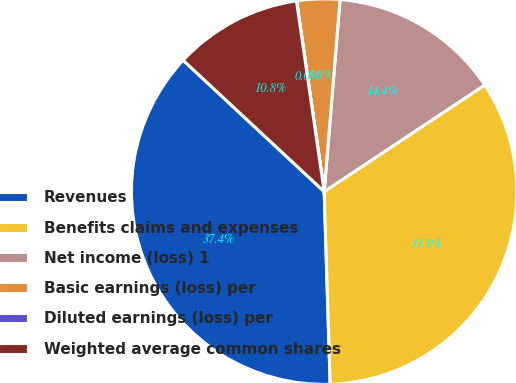Convert chart to OTSL. <chart><loc_0><loc_0><loc_500><loc_500><pie_chart><fcel>Revenues<fcel>Benefits claims and expenses<fcel>Net income (loss) 1<fcel>Basic earnings (loss) per<fcel>Diluted earnings (loss) per<fcel>Weighted average common shares<nl><fcel>37.43%<fcel>33.84%<fcel>14.36%<fcel>3.6%<fcel>0.01%<fcel>10.77%<nl></chart> 